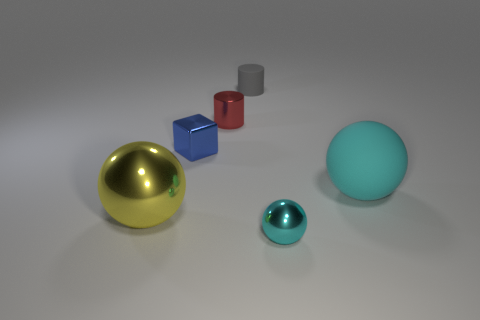The other thing that is the same color as the large rubber thing is what shape?
Give a very brief answer. Sphere. There is a red shiny object that is the same size as the block; what is its shape?
Keep it short and to the point. Cylinder. There is another ball that is the same color as the large matte ball; what material is it?
Offer a terse response. Metal. Are there any things to the left of the big cyan object?
Offer a terse response. Yes. Are there any other metallic objects that have the same shape as the yellow thing?
Give a very brief answer. Yes. There is a large object that is on the right side of the yellow thing; is it the same shape as the small red metal object that is in front of the tiny gray cylinder?
Your answer should be very brief. No. Is there a purple metal object of the same size as the gray object?
Keep it short and to the point. No. Are there an equal number of cyan spheres behind the gray cylinder and gray cylinders that are in front of the small blue metallic block?
Offer a very short reply. Yes. Do the cyan thing that is on the left side of the big rubber thing and the cyan ball on the right side of the cyan metal sphere have the same material?
Provide a short and direct response. No. What is the material of the small blue thing?
Your answer should be compact. Metal. 